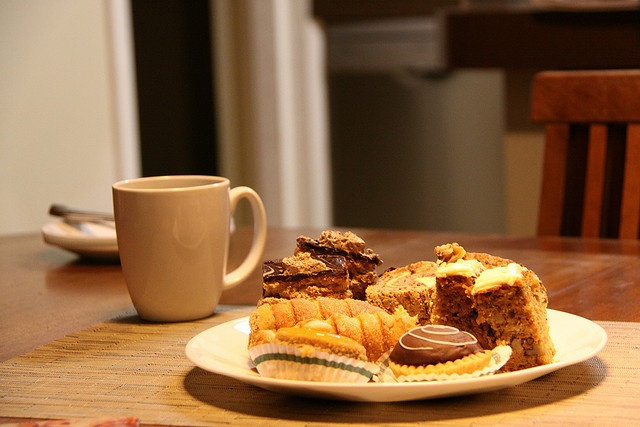Describe the objects in this image and their specific colors. I can see dining table in tan, brown, and maroon tones, cup in tan, brown, and maroon tones, chair in tan, maroon, black, and brown tones, cake in tan, maroon, brown, and orange tones, and cake in tan, maroon, brown, and black tones in this image. 